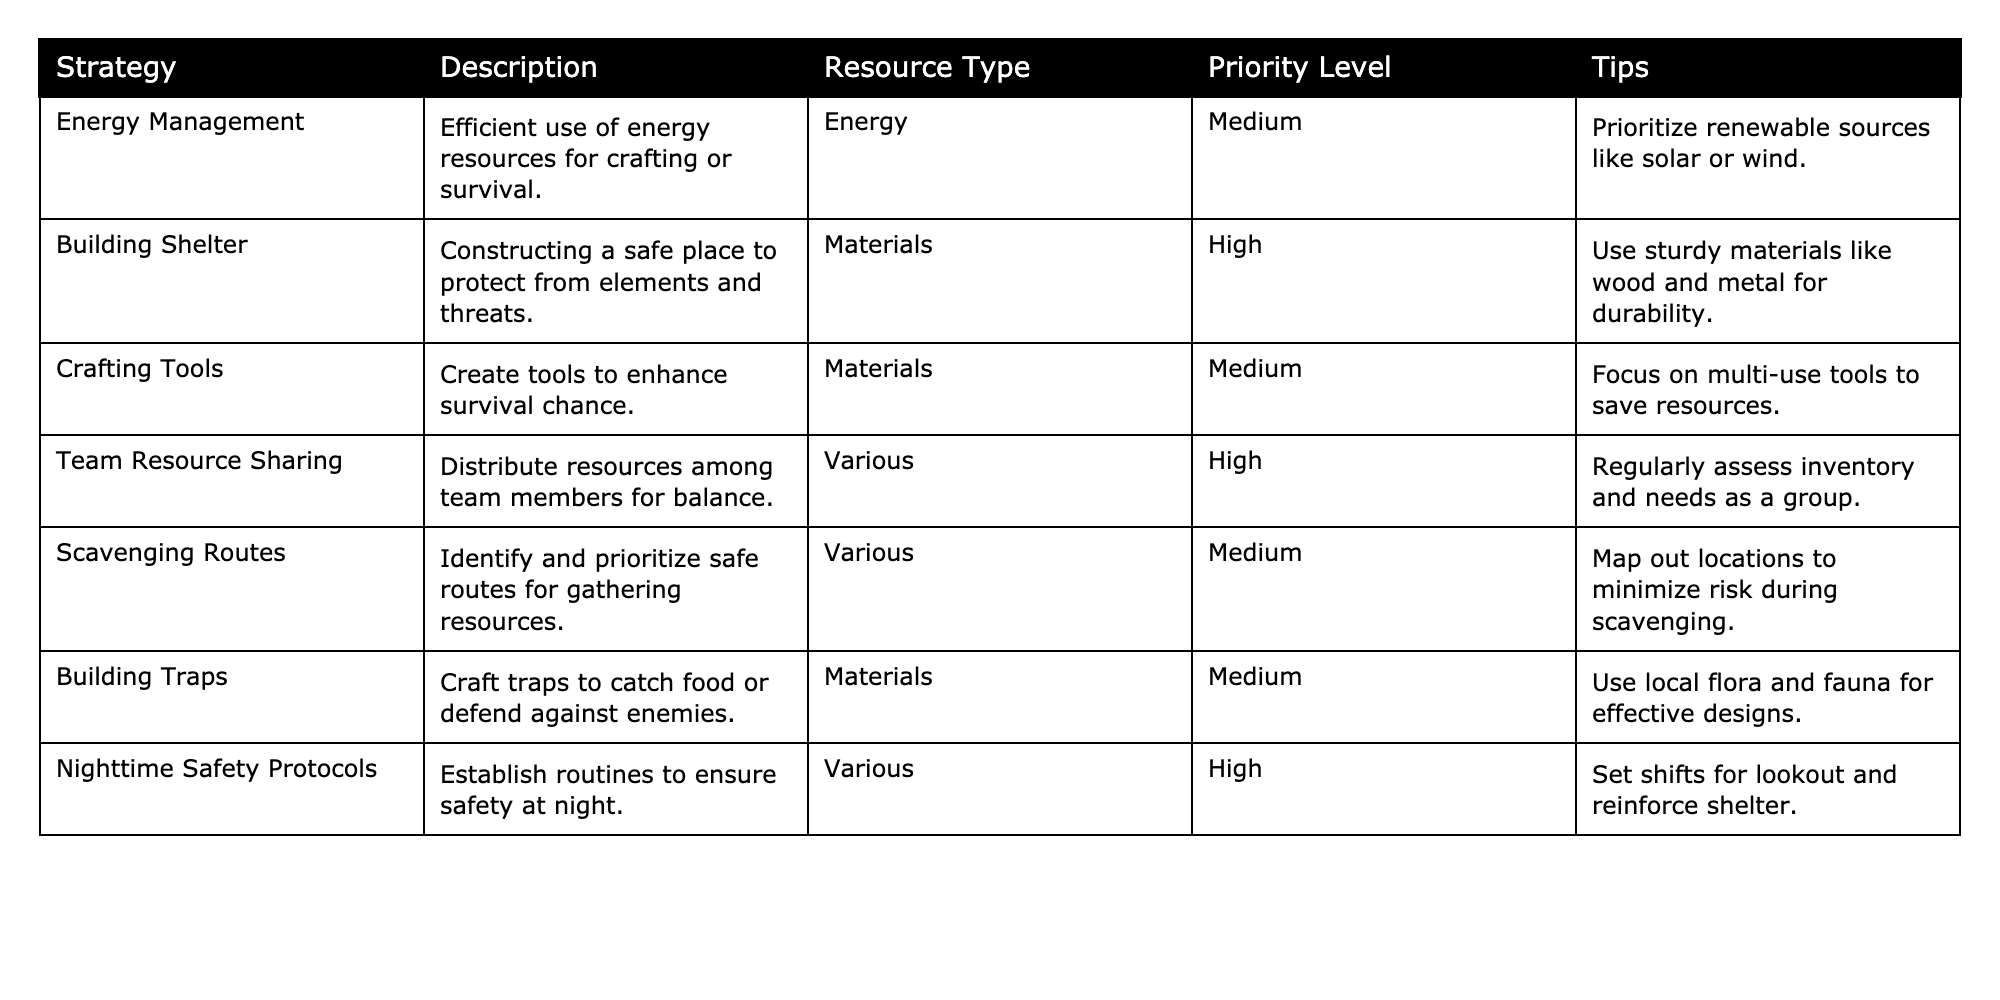What's the highest priority resource management strategy in the table? The highest priority level is "High," which appears in the strategies "Building Shelter," "Team Resource Sharing," and "Nighttime Safety Protocols." Among these, "Building Shelter" is the first listed, so it is a candidate for the highest priority.
Answer: Building Shelter How many strategies focus on materials as their resource type? From the table, the strategies that focus on materials are "Building Shelter," "Crafting Tools," and "Building Traps." Counting these gives a total of 3 strategies.
Answer: 3 Is it true that "Energy Management" has a low priority level? In the table, the priority level for "Energy Management" is listed as "Medium," which means it does not have a low priority. Therefore, the statement is not true.
Answer: False Which strategy involves distributing resources among team members? The strategy that involves distributing resources among team members is "Team Resource Sharing," as it explicitly mentions balancing resources among the group.
Answer: Team Resource Sharing What is the average priority level of strategies that use various resource types? The strategies using various resource types are "Team Resource Sharing," "Scavenging Routes," and "Nighttime Safety Protocols," which have priority levels of High, Medium, and High, respectively. Converting these to numerical values (High = 3, Medium = 2), the average priority is (3 + 2 + 3) / 3 = 2.67, which rounds to Medium.
Answer: Medium Which strategy is aimed at ensuring safety specifically at night? The strategy aimed at ensuring safety at night is "Nighttime Safety Protocols," as indicated in its description.
Answer: Nighttime Safety Protocols What tips are provided for scavenging routes? The tip for scavenging routes suggests mapping out locations to minimize risk during the resource gathering.
Answer: Map out locations to minimize risk How many strategies require crafting? The strategies that require crafting are "Crafting Tools," "Building Shelter," and "Building Traps," totaling 3 strategies that involve crafting.
Answer: 3 Identify one strategy that prioritizes renewable resources for energy. The strategy that prioritizes renewable resources for energy is "Energy Management," which highlights the use of renewable sources like solar or wind.
Answer: Energy Management 